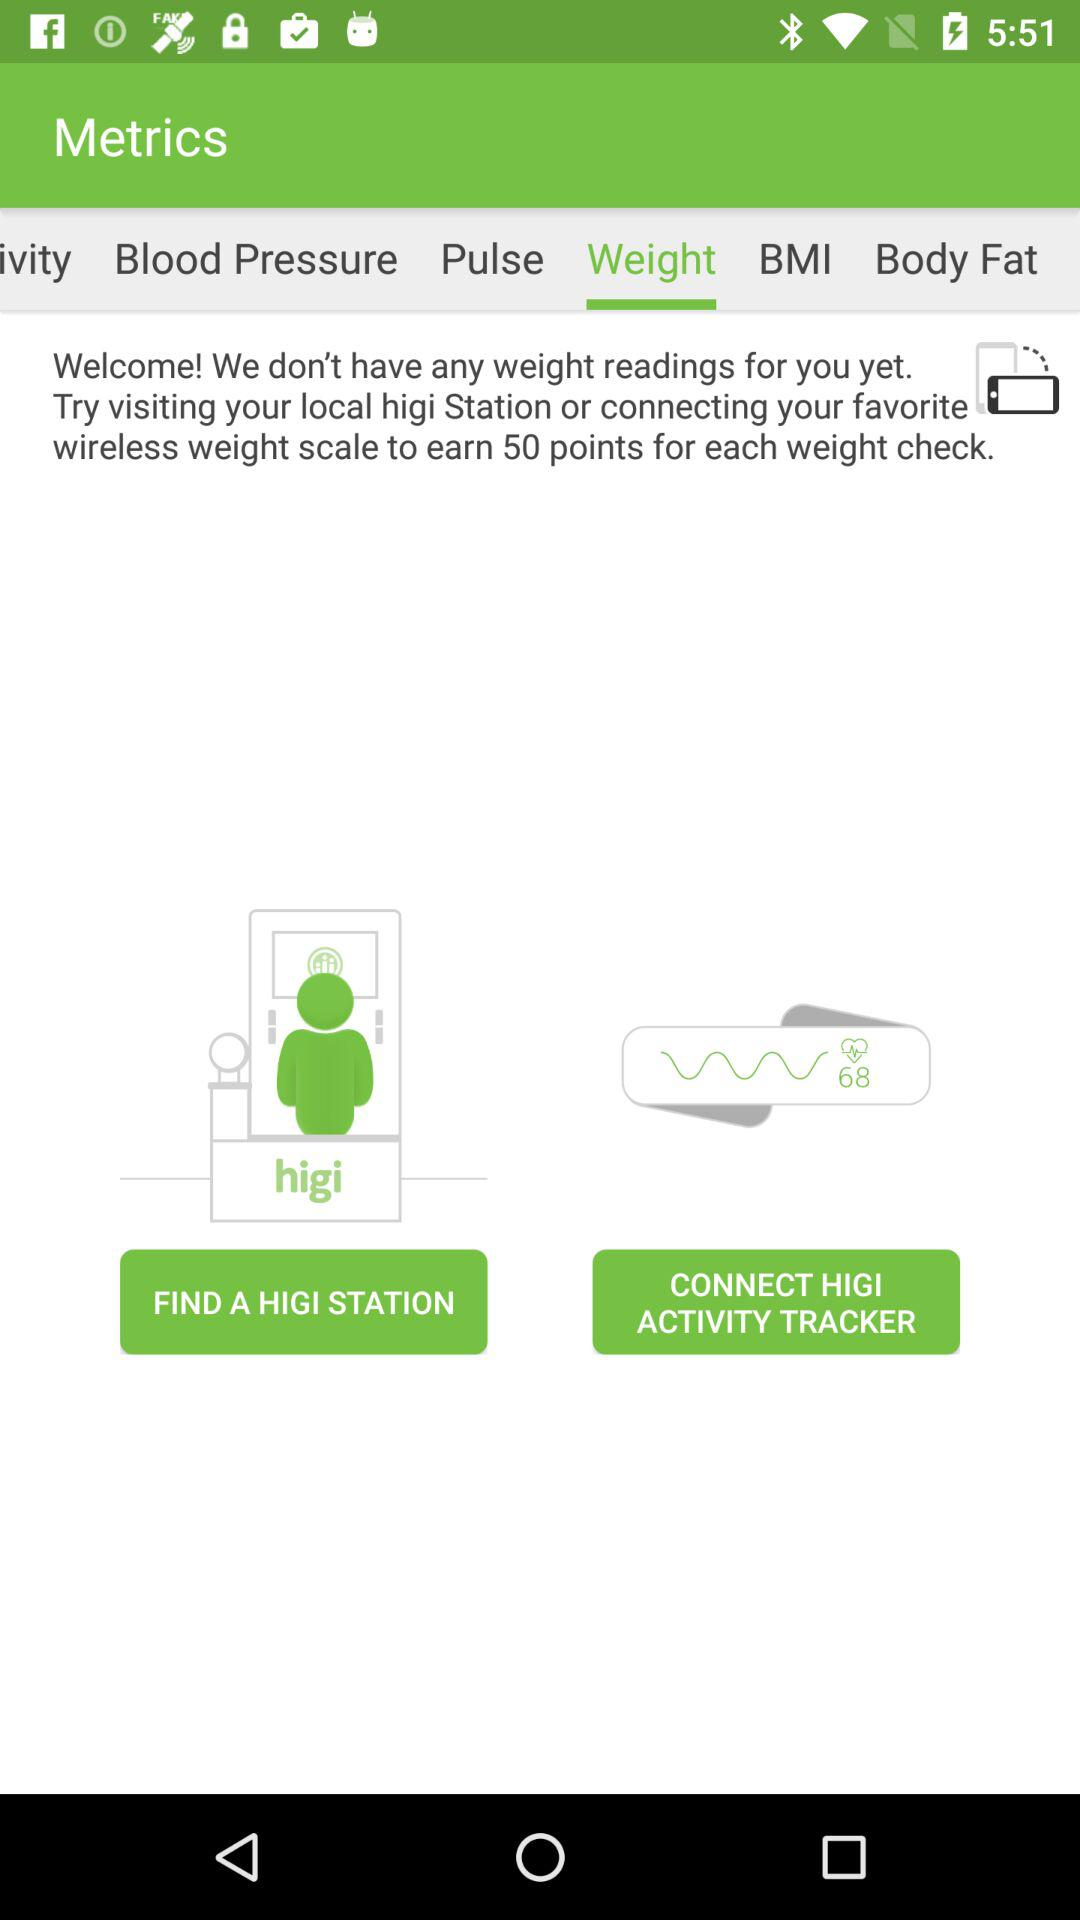Which tab is selected? The selected tab is "Weight". 